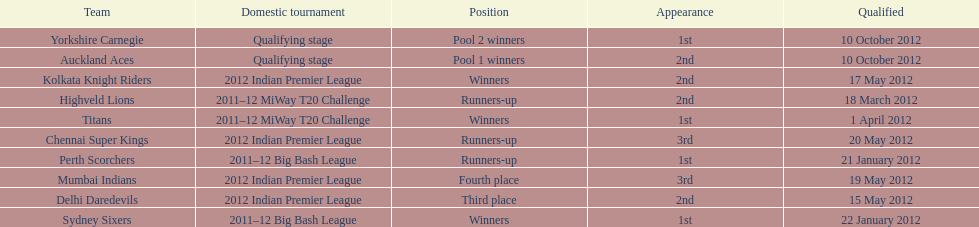Which game came in first in the 2012 indian premier league? Kolkata Knight Riders. 